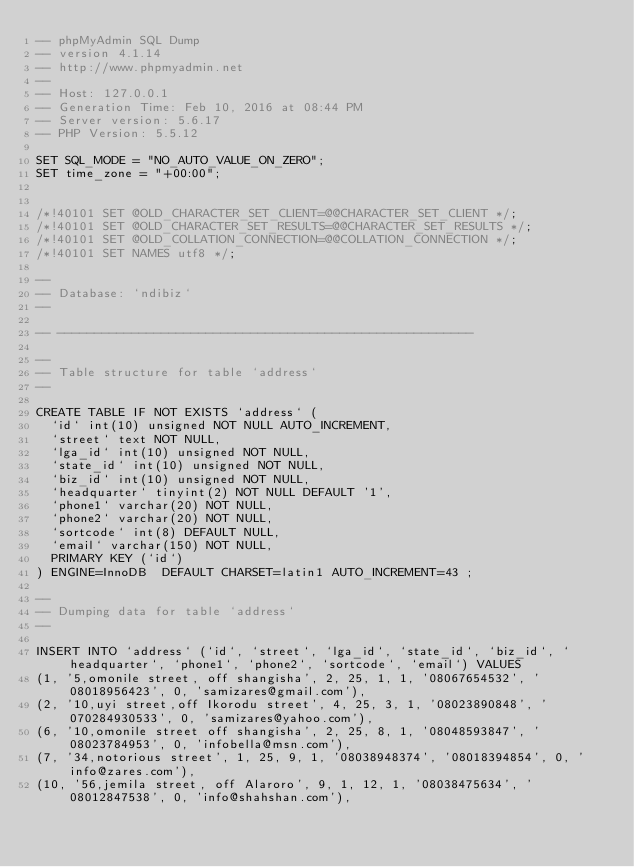Convert code to text. <code><loc_0><loc_0><loc_500><loc_500><_SQL_>-- phpMyAdmin SQL Dump
-- version 4.1.14
-- http://www.phpmyadmin.net
--
-- Host: 127.0.0.1
-- Generation Time: Feb 10, 2016 at 08:44 PM
-- Server version: 5.6.17
-- PHP Version: 5.5.12

SET SQL_MODE = "NO_AUTO_VALUE_ON_ZERO";
SET time_zone = "+00:00";


/*!40101 SET @OLD_CHARACTER_SET_CLIENT=@@CHARACTER_SET_CLIENT */;
/*!40101 SET @OLD_CHARACTER_SET_RESULTS=@@CHARACTER_SET_RESULTS */;
/*!40101 SET @OLD_COLLATION_CONNECTION=@@COLLATION_CONNECTION */;
/*!40101 SET NAMES utf8 */;

--
-- Database: `ndibiz`
--

-- --------------------------------------------------------

--
-- Table structure for table `address`
--

CREATE TABLE IF NOT EXISTS `address` (
  `id` int(10) unsigned NOT NULL AUTO_INCREMENT,
  `street` text NOT NULL,
  `lga_id` int(10) unsigned NOT NULL,
  `state_id` int(10) unsigned NOT NULL,
  `biz_id` int(10) unsigned NOT NULL,
  `headquarter` tinyint(2) NOT NULL DEFAULT '1',
  `phone1` varchar(20) NOT NULL,
  `phone2` varchar(20) NOT NULL,
  `sortcode` int(8) DEFAULT NULL,
  `email` varchar(150) NOT NULL,
  PRIMARY KEY (`id`)
) ENGINE=InnoDB  DEFAULT CHARSET=latin1 AUTO_INCREMENT=43 ;

--
-- Dumping data for table `address`
--

INSERT INTO `address` (`id`, `street`, `lga_id`, `state_id`, `biz_id`, `headquarter`, `phone1`, `phone2`, `sortcode`, `email`) VALUES
(1, '5,omonile street, off shangisha', 2, 25, 1, 1, '08067654532', '08018956423', 0, 'samizares@gmail.com'),
(2, '10,uyi street,off Ikorodu street', 4, 25, 3, 1, '08023890848', '070284930533', 0, 'samizares@yahoo.com'),
(6, '10,omonile street off shangisha', 2, 25, 8, 1, '08048593847', '08023784953', 0, 'infobella@msn.com'),
(7, '34,notorious street', 1, 25, 9, 1, '08038948374', '08018394854', 0, 'info@zares.com'),
(10, '56,jemila street, off Alaroro', 9, 1, 12, 1, '08038475634', '08012847538', 0, 'info@shahshan.com'),</code> 